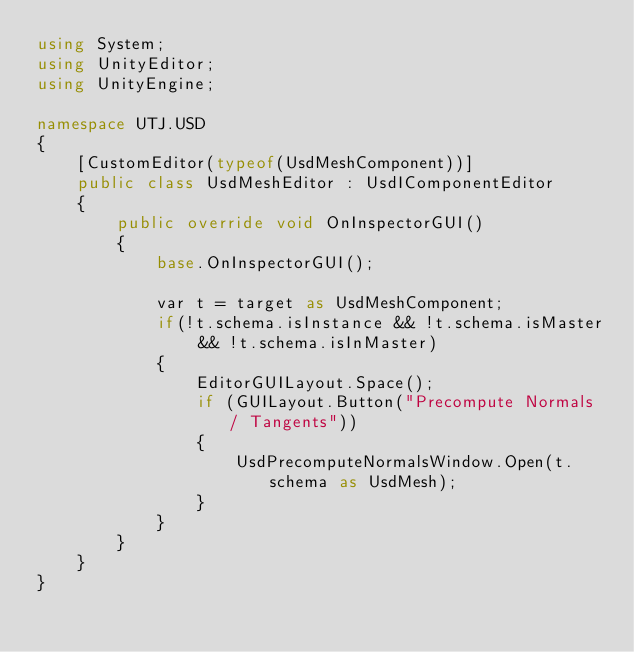<code> <loc_0><loc_0><loc_500><loc_500><_C#_>using System;
using UnityEditor;
using UnityEngine;

namespace UTJ.USD
{
    [CustomEditor(typeof(UsdMeshComponent))]
    public class UsdMeshEditor : UsdIComponentEditor
    {
        public override void OnInspectorGUI()
        {
            base.OnInspectorGUI();

            var t = target as UsdMeshComponent;
            if(!t.schema.isInstance && !t.schema.isMaster && !t.schema.isInMaster)
            {
                EditorGUILayout.Space();
                if (GUILayout.Button("Precompute Normals / Tangents"))
                {
                    UsdPrecomputeNormalsWindow.Open(t.schema as UsdMesh);
                }
            }
        }
    }
}</code> 